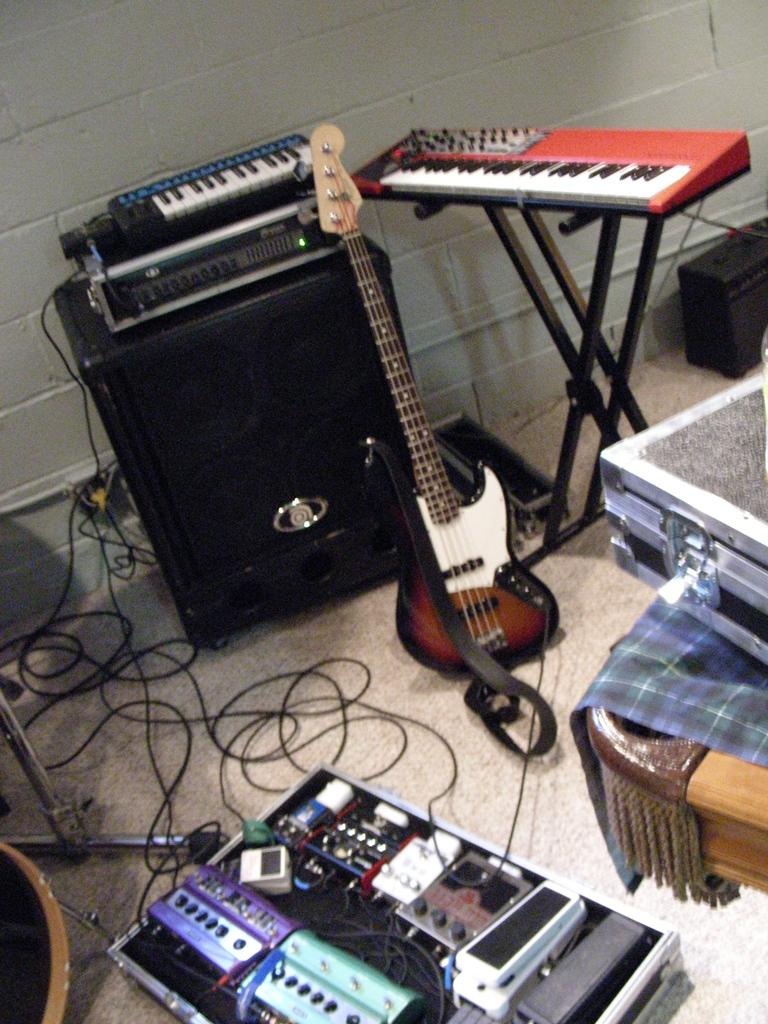What type of objects can be seen in the image? There are musical instruments in the image. Where are the musical instruments located? The musical instruments are on the floor. What type of plants can be seen growing in the prison in the image? There are no plants or prison present in the image; it only features musical instruments on the floor. 